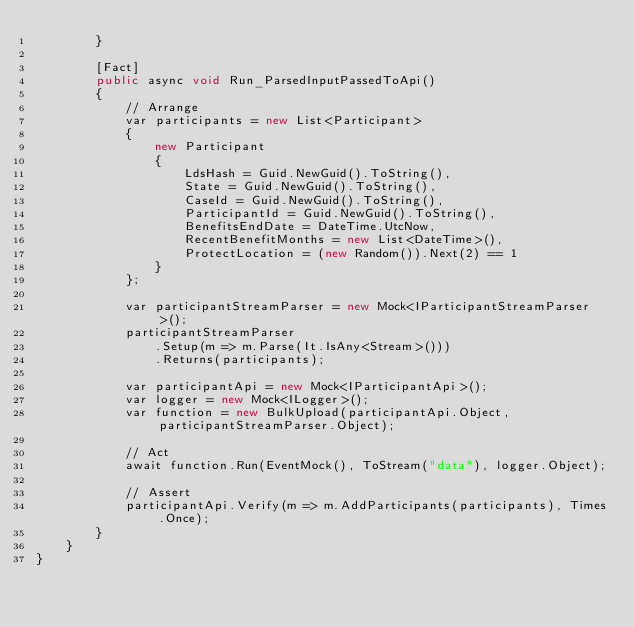Convert code to text. <code><loc_0><loc_0><loc_500><loc_500><_C#_>        }

        [Fact]
        public async void Run_ParsedInputPassedToApi()
        {
            // Arrange
            var participants = new List<Participant>
            {
                new Participant
                {
                    LdsHash = Guid.NewGuid().ToString(),
                    State = Guid.NewGuid().ToString(),
                    CaseId = Guid.NewGuid().ToString(),
                    ParticipantId = Guid.NewGuid().ToString(),
                    BenefitsEndDate = DateTime.UtcNow,
                    RecentBenefitMonths = new List<DateTime>(),
                    ProtectLocation = (new Random()).Next(2) == 1
                }
            };

            var participantStreamParser = new Mock<IParticipantStreamParser>();
            participantStreamParser
                .Setup(m => m.Parse(It.IsAny<Stream>()))
                .Returns(participants);

            var participantApi = new Mock<IParticipantApi>();
            var logger = new Mock<ILogger>();
            var function = new BulkUpload(participantApi.Object, participantStreamParser.Object);

            // Act
            await function.Run(EventMock(), ToStream("data"), logger.Object);

            // Assert
            participantApi.Verify(m => m.AddParticipants(participants), Times.Once);
        }
    }
}
</code> 